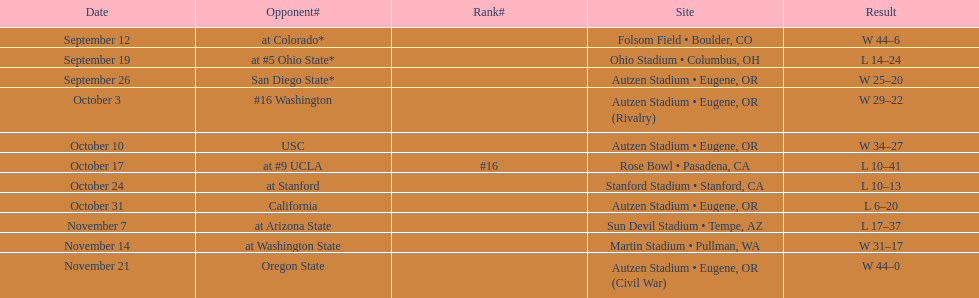What is the count of away games? 6. 